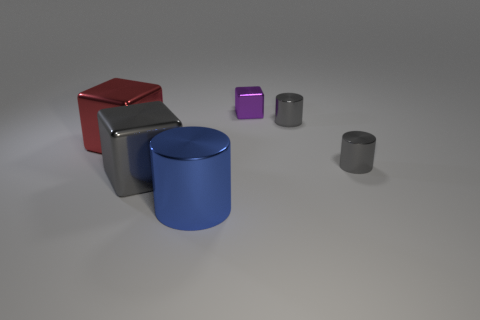There is a big metallic thing on the right side of the gray object that is left of the object that is in front of the gray metal cube; what is its shape?
Provide a succinct answer. Cylinder. Do the gray metallic thing that is to the left of the blue metal cylinder and the red object have the same size?
Keep it short and to the point. Yes. There is a object that is both behind the red shiny cube and in front of the purple metal thing; what is its shape?
Your answer should be very brief. Cylinder. What is the color of the cube on the right side of the shiny cylinder on the left side of the cube that is to the right of the large blue metal object?
Make the answer very short. Purple. What color is the other large thing that is the same shape as the big red thing?
Your answer should be very brief. Gray. Are there the same number of cubes that are on the right side of the gray shiny cube and purple metallic things?
Offer a terse response. Yes. How many spheres are big yellow objects or purple objects?
Make the answer very short. 0. There is another tiny cube that is the same material as the gray block; what is its color?
Ensure brevity in your answer.  Purple. Are the tiny cube and the gray thing that is to the left of the large blue thing made of the same material?
Offer a terse response. Yes. What number of things are either small gray shiny cylinders or big purple balls?
Provide a succinct answer. 2. 